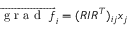<formula> <loc_0><loc_0><loc_500><loc_500>\overrightarrow { g r a d f } _ { i } = ( R I R ^ { T } ) _ { i j } x _ { j }</formula> 